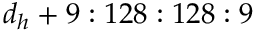Convert formula to latex. <formula><loc_0><loc_0><loc_500><loc_500>d _ { h } + 9 \colon 1 2 8 \colon 1 2 8 \colon 9</formula> 